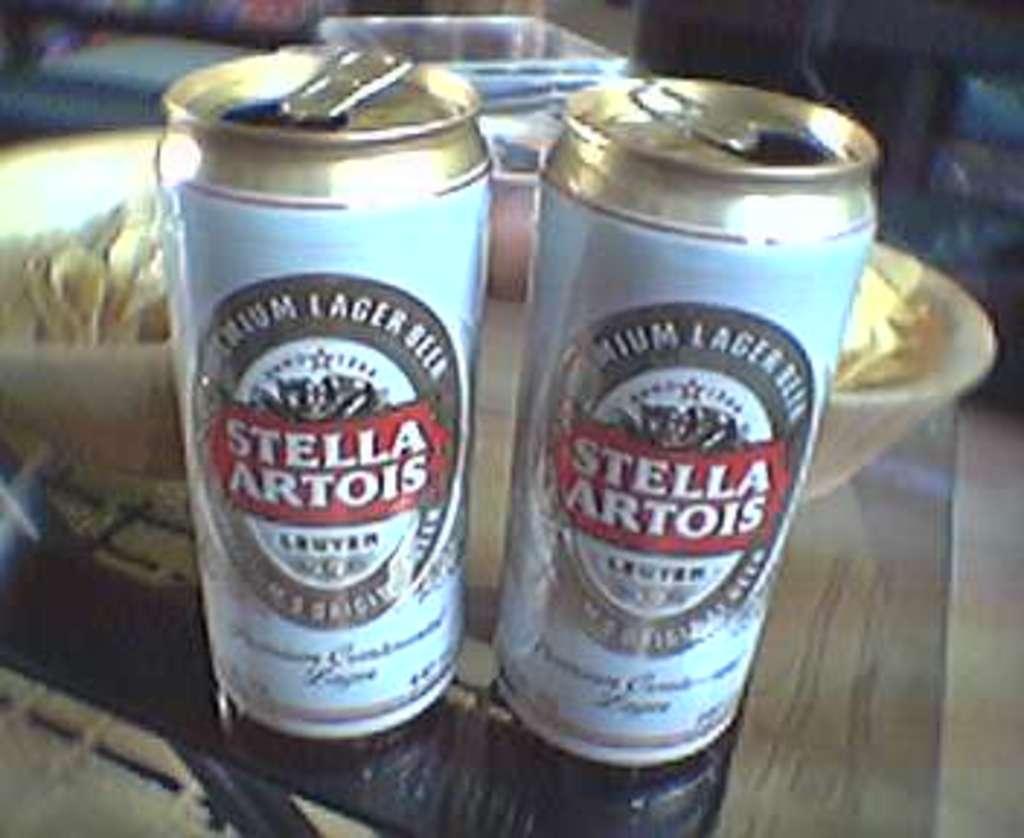What is the brand of these two beers?
Ensure brevity in your answer.  Stella artois. What kind of beer is this?
Keep it short and to the point. Stella artois. 